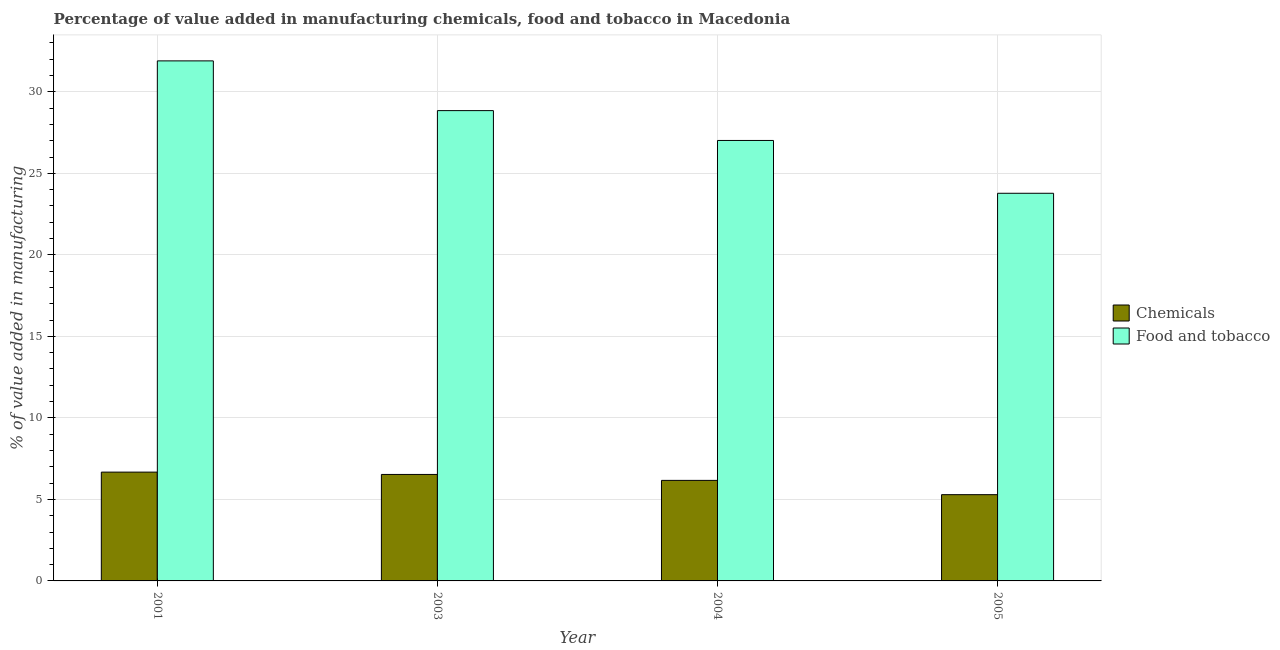How many different coloured bars are there?
Your answer should be very brief. 2. Are the number of bars on each tick of the X-axis equal?
Offer a terse response. Yes. What is the label of the 2nd group of bars from the left?
Provide a succinct answer. 2003. In how many cases, is the number of bars for a given year not equal to the number of legend labels?
Your answer should be compact. 0. What is the value added by  manufacturing chemicals in 2003?
Your answer should be very brief. 6.53. Across all years, what is the maximum value added by  manufacturing chemicals?
Provide a short and direct response. 6.67. Across all years, what is the minimum value added by  manufacturing chemicals?
Keep it short and to the point. 5.29. What is the total value added by  manufacturing chemicals in the graph?
Offer a very short reply. 24.66. What is the difference between the value added by  manufacturing chemicals in 2003 and that in 2004?
Give a very brief answer. 0.36. What is the difference between the value added by manufacturing food and tobacco in 2005 and the value added by  manufacturing chemicals in 2001?
Provide a short and direct response. -8.12. What is the average value added by  manufacturing chemicals per year?
Ensure brevity in your answer.  6.17. In the year 2003, what is the difference between the value added by manufacturing food and tobacco and value added by  manufacturing chemicals?
Provide a short and direct response. 0. In how many years, is the value added by manufacturing food and tobacco greater than 17 %?
Give a very brief answer. 4. What is the ratio of the value added by manufacturing food and tobacco in 2004 to that in 2005?
Offer a terse response. 1.14. Is the value added by manufacturing food and tobacco in 2001 less than that in 2004?
Keep it short and to the point. No. What is the difference between the highest and the second highest value added by  manufacturing chemicals?
Your answer should be compact. 0.14. What is the difference between the highest and the lowest value added by manufacturing food and tobacco?
Your response must be concise. 8.12. What does the 2nd bar from the left in 2005 represents?
Provide a succinct answer. Food and tobacco. What does the 1st bar from the right in 2001 represents?
Your answer should be very brief. Food and tobacco. How many bars are there?
Provide a succinct answer. 8. What is the title of the graph?
Provide a succinct answer. Percentage of value added in manufacturing chemicals, food and tobacco in Macedonia. Does "Investment" appear as one of the legend labels in the graph?
Keep it short and to the point. No. What is the label or title of the Y-axis?
Offer a very short reply. % of value added in manufacturing. What is the % of value added in manufacturing in Chemicals in 2001?
Your answer should be very brief. 6.67. What is the % of value added in manufacturing in Food and tobacco in 2001?
Offer a terse response. 31.9. What is the % of value added in manufacturing in Chemicals in 2003?
Offer a terse response. 6.53. What is the % of value added in manufacturing in Food and tobacco in 2003?
Keep it short and to the point. 28.85. What is the % of value added in manufacturing of Chemicals in 2004?
Provide a short and direct response. 6.17. What is the % of value added in manufacturing of Food and tobacco in 2004?
Ensure brevity in your answer.  27.01. What is the % of value added in manufacturing in Chemicals in 2005?
Offer a very short reply. 5.29. What is the % of value added in manufacturing in Food and tobacco in 2005?
Your answer should be compact. 23.78. Across all years, what is the maximum % of value added in manufacturing in Chemicals?
Offer a terse response. 6.67. Across all years, what is the maximum % of value added in manufacturing of Food and tobacco?
Provide a short and direct response. 31.9. Across all years, what is the minimum % of value added in manufacturing of Chemicals?
Your response must be concise. 5.29. Across all years, what is the minimum % of value added in manufacturing in Food and tobacco?
Offer a terse response. 23.78. What is the total % of value added in manufacturing of Chemicals in the graph?
Offer a very short reply. 24.66. What is the total % of value added in manufacturing of Food and tobacco in the graph?
Your answer should be compact. 111.53. What is the difference between the % of value added in manufacturing of Chemicals in 2001 and that in 2003?
Provide a succinct answer. 0.14. What is the difference between the % of value added in manufacturing in Food and tobacco in 2001 and that in 2003?
Keep it short and to the point. 3.05. What is the difference between the % of value added in manufacturing in Chemicals in 2001 and that in 2004?
Your answer should be compact. 0.51. What is the difference between the % of value added in manufacturing of Food and tobacco in 2001 and that in 2004?
Provide a succinct answer. 4.88. What is the difference between the % of value added in manufacturing in Chemicals in 2001 and that in 2005?
Make the answer very short. 1.38. What is the difference between the % of value added in manufacturing in Food and tobacco in 2001 and that in 2005?
Your response must be concise. 8.12. What is the difference between the % of value added in manufacturing of Chemicals in 2003 and that in 2004?
Give a very brief answer. 0.36. What is the difference between the % of value added in manufacturing in Food and tobacco in 2003 and that in 2004?
Make the answer very short. 1.83. What is the difference between the % of value added in manufacturing of Chemicals in 2003 and that in 2005?
Your answer should be compact. 1.24. What is the difference between the % of value added in manufacturing in Food and tobacco in 2003 and that in 2005?
Ensure brevity in your answer.  5.07. What is the difference between the % of value added in manufacturing of Chemicals in 2004 and that in 2005?
Ensure brevity in your answer.  0.88. What is the difference between the % of value added in manufacturing of Food and tobacco in 2004 and that in 2005?
Provide a short and direct response. 3.24. What is the difference between the % of value added in manufacturing in Chemicals in 2001 and the % of value added in manufacturing in Food and tobacco in 2003?
Your response must be concise. -22.17. What is the difference between the % of value added in manufacturing of Chemicals in 2001 and the % of value added in manufacturing of Food and tobacco in 2004?
Your answer should be compact. -20.34. What is the difference between the % of value added in manufacturing of Chemicals in 2001 and the % of value added in manufacturing of Food and tobacco in 2005?
Offer a very short reply. -17.1. What is the difference between the % of value added in manufacturing in Chemicals in 2003 and the % of value added in manufacturing in Food and tobacco in 2004?
Give a very brief answer. -20.48. What is the difference between the % of value added in manufacturing of Chemicals in 2003 and the % of value added in manufacturing of Food and tobacco in 2005?
Provide a succinct answer. -17.25. What is the difference between the % of value added in manufacturing in Chemicals in 2004 and the % of value added in manufacturing in Food and tobacco in 2005?
Your answer should be compact. -17.61. What is the average % of value added in manufacturing in Chemicals per year?
Make the answer very short. 6.17. What is the average % of value added in manufacturing of Food and tobacco per year?
Your answer should be compact. 27.88. In the year 2001, what is the difference between the % of value added in manufacturing in Chemicals and % of value added in manufacturing in Food and tobacco?
Keep it short and to the point. -25.22. In the year 2003, what is the difference between the % of value added in manufacturing in Chemicals and % of value added in manufacturing in Food and tobacco?
Your answer should be compact. -22.32. In the year 2004, what is the difference between the % of value added in manufacturing in Chemicals and % of value added in manufacturing in Food and tobacco?
Your answer should be compact. -20.85. In the year 2005, what is the difference between the % of value added in manufacturing in Chemicals and % of value added in manufacturing in Food and tobacco?
Your response must be concise. -18.48. What is the ratio of the % of value added in manufacturing in Food and tobacco in 2001 to that in 2003?
Ensure brevity in your answer.  1.11. What is the ratio of the % of value added in manufacturing of Chemicals in 2001 to that in 2004?
Provide a succinct answer. 1.08. What is the ratio of the % of value added in manufacturing of Food and tobacco in 2001 to that in 2004?
Give a very brief answer. 1.18. What is the ratio of the % of value added in manufacturing in Chemicals in 2001 to that in 2005?
Your answer should be very brief. 1.26. What is the ratio of the % of value added in manufacturing in Food and tobacco in 2001 to that in 2005?
Your answer should be very brief. 1.34. What is the ratio of the % of value added in manufacturing in Chemicals in 2003 to that in 2004?
Provide a succinct answer. 1.06. What is the ratio of the % of value added in manufacturing of Food and tobacco in 2003 to that in 2004?
Give a very brief answer. 1.07. What is the ratio of the % of value added in manufacturing in Chemicals in 2003 to that in 2005?
Offer a very short reply. 1.23. What is the ratio of the % of value added in manufacturing of Food and tobacco in 2003 to that in 2005?
Keep it short and to the point. 1.21. What is the ratio of the % of value added in manufacturing of Chemicals in 2004 to that in 2005?
Provide a succinct answer. 1.17. What is the ratio of the % of value added in manufacturing of Food and tobacco in 2004 to that in 2005?
Your response must be concise. 1.14. What is the difference between the highest and the second highest % of value added in manufacturing of Chemicals?
Keep it short and to the point. 0.14. What is the difference between the highest and the second highest % of value added in manufacturing of Food and tobacco?
Your response must be concise. 3.05. What is the difference between the highest and the lowest % of value added in manufacturing in Chemicals?
Keep it short and to the point. 1.38. What is the difference between the highest and the lowest % of value added in manufacturing of Food and tobacco?
Your response must be concise. 8.12. 